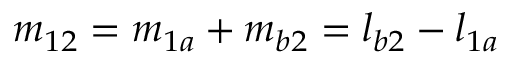Convert formula to latex. <formula><loc_0><loc_0><loc_500><loc_500>m _ { 1 2 } = m _ { 1 a } + m _ { b 2 } = l _ { b 2 } - l _ { 1 a }</formula> 